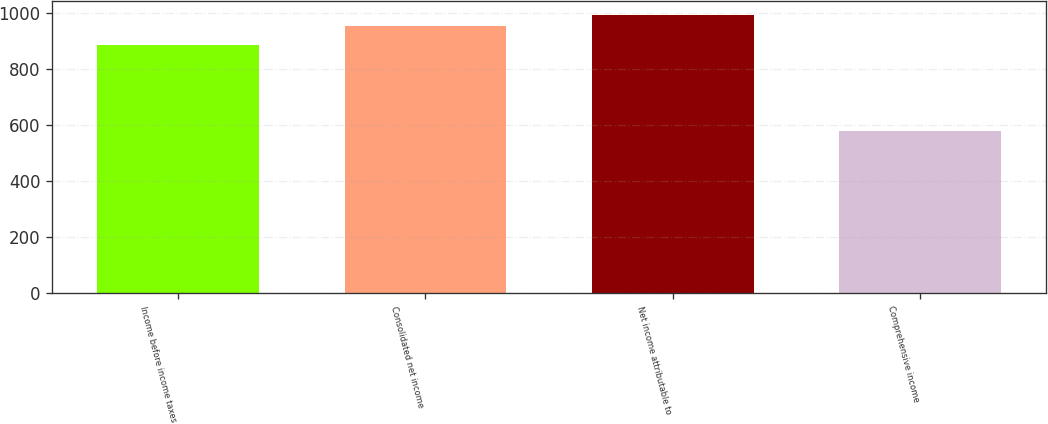Convert chart. <chart><loc_0><loc_0><loc_500><loc_500><bar_chart><fcel>Income before income taxes<fcel>Consolidated net income<fcel>Net income attributable to<fcel>Comprehensive income<nl><fcel>885.3<fcel>953.2<fcel>990.75<fcel>577.7<nl></chart> 